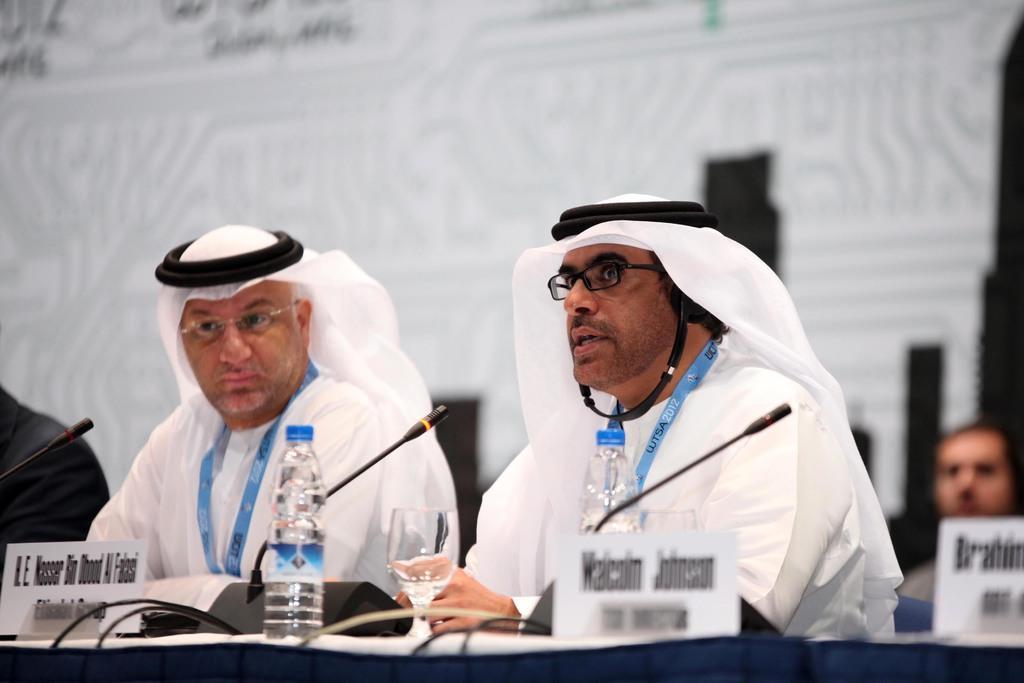Can you describe this image briefly? In the foreground of the picture there are water bottles, mics, name plates, table, cables and people sitting. The background is blurred. 